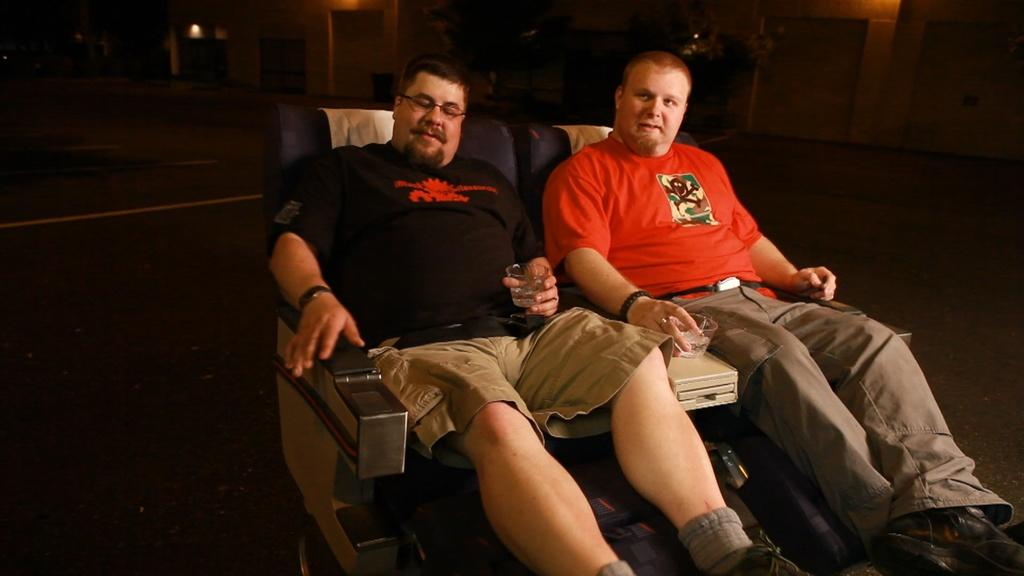How many people are in the image? There are two persons in the image. What are the persons doing in the image? The persons are sitting on chairs and holding glasses. What can be seen in the background of the image? There is a wall in the background of the image. How many ants can be seen crawling on the collar of the person in the image? There are no ants or collars visible in the image. What fact is being discussed by the persons in the image? The image does not provide any information about a fact being discussed by the persons. 